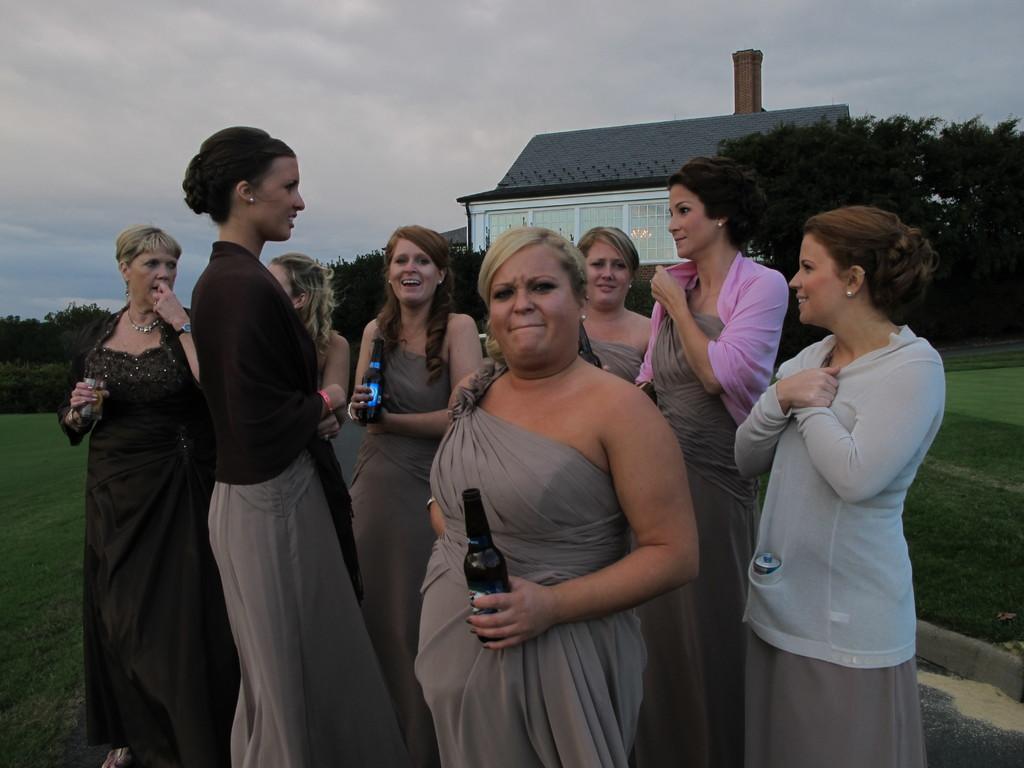Could you give a brief overview of what you see in this image? There are women standing and these two women are holding bottles and we can see grass. In the background we can see trees,house and sky with clouds. 